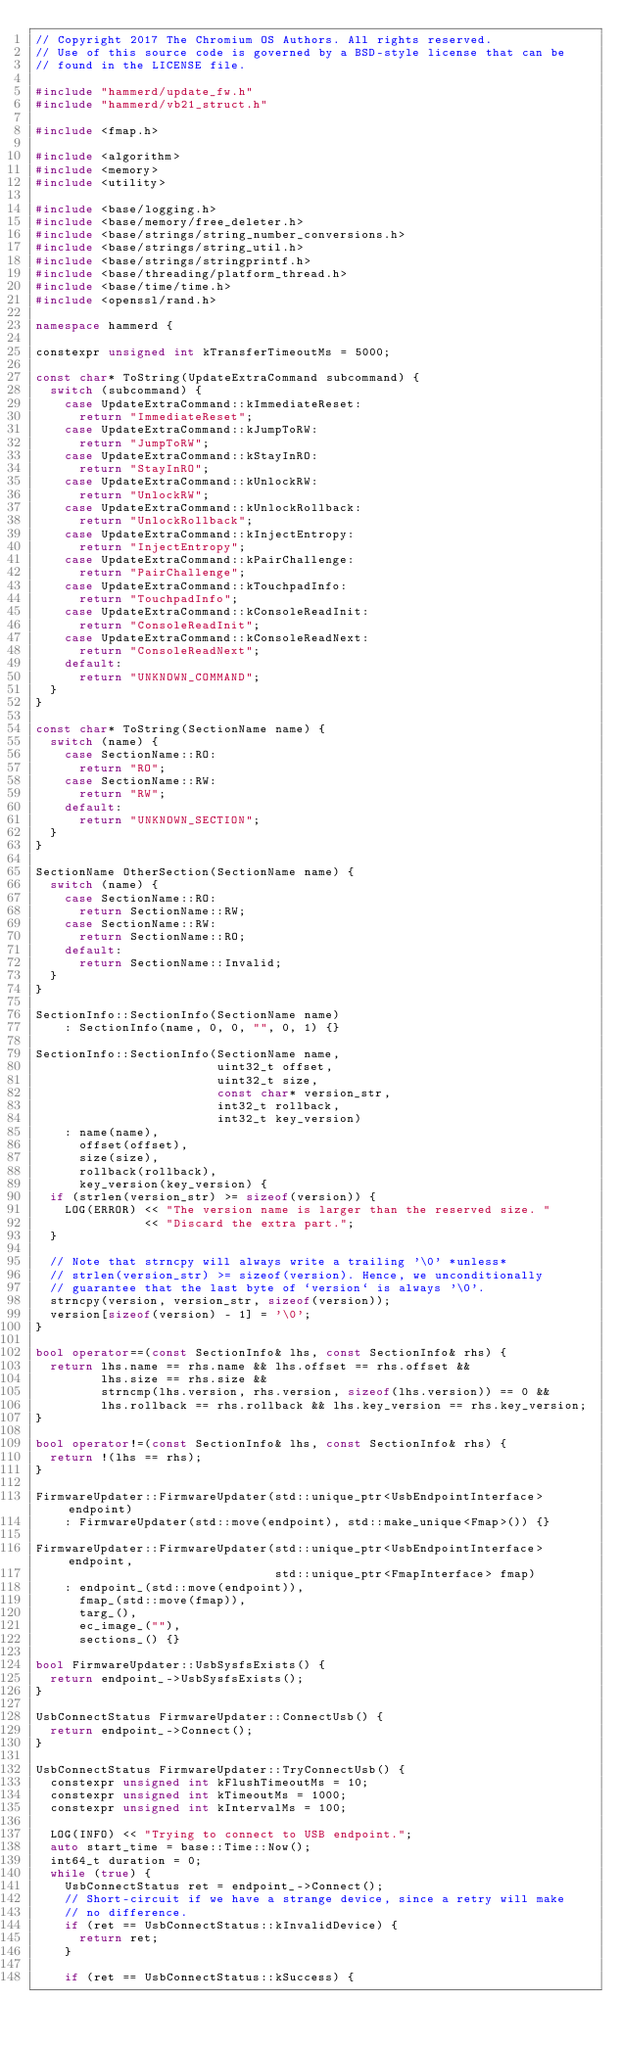<code> <loc_0><loc_0><loc_500><loc_500><_C++_>// Copyright 2017 The Chromium OS Authors. All rights reserved.
// Use of this source code is governed by a BSD-style license that can be
// found in the LICENSE file.

#include "hammerd/update_fw.h"
#include "hammerd/vb21_struct.h"

#include <fmap.h>

#include <algorithm>
#include <memory>
#include <utility>

#include <base/logging.h>
#include <base/memory/free_deleter.h>
#include <base/strings/string_number_conversions.h>
#include <base/strings/string_util.h>
#include <base/strings/stringprintf.h>
#include <base/threading/platform_thread.h>
#include <base/time/time.h>
#include <openssl/rand.h>

namespace hammerd {

constexpr unsigned int kTransferTimeoutMs = 5000;

const char* ToString(UpdateExtraCommand subcommand) {
  switch (subcommand) {
    case UpdateExtraCommand::kImmediateReset:
      return "ImmediateReset";
    case UpdateExtraCommand::kJumpToRW:
      return "JumpToRW";
    case UpdateExtraCommand::kStayInRO:
      return "StayInRO";
    case UpdateExtraCommand::kUnlockRW:
      return "UnlockRW";
    case UpdateExtraCommand::kUnlockRollback:
      return "UnlockRollback";
    case UpdateExtraCommand::kInjectEntropy:
      return "InjectEntropy";
    case UpdateExtraCommand::kPairChallenge:
      return "PairChallenge";
    case UpdateExtraCommand::kTouchpadInfo:
      return "TouchpadInfo";
    case UpdateExtraCommand::kConsoleReadInit:
      return "ConsoleReadInit";
    case UpdateExtraCommand::kConsoleReadNext:
      return "ConsoleReadNext";
    default:
      return "UNKNOWN_COMMAND";
  }
}

const char* ToString(SectionName name) {
  switch (name) {
    case SectionName::RO:
      return "RO";
    case SectionName::RW:
      return "RW";
    default:
      return "UNKNOWN_SECTION";
  }
}

SectionName OtherSection(SectionName name) {
  switch (name) {
    case SectionName::RO:
      return SectionName::RW;
    case SectionName::RW:
      return SectionName::RO;
    default:
      return SectionName::Invalid;
  }
}

SectionInfo::SectionInfo(SectionName name)
    : SectionInfo(name, 0, 0, "", 0, 1) {}

SectionInfo::SectionInfo(SectionName name,
                         uint32_t offset,
                         uint32_t size,
                         const char* version_str,
                         int32_t rollback,
                         int32_t key_version)
    : name(name),
      offset(offset),
      size(size),
      rollback(rollback),
      key_version(key_version) {
  if (strlen(version_str) >= sizeof(version)) {
    LOG(ERROR) << "The version name is larger than the reserved size. "
               << "Discard the extra part.";
  }

  // Note that strncpy will always write a trailing '\0' *unless*
  // strlen(version_str) >= sizeof(version). Hence, we unconditionally
  // guarantee that the last byte of `version` is always '\0'.
  strncpy(version, version_str, sizeof(version));
  version[sizeof(version) - 1] = '\0';
}

bool operator==(const SectionInfo& lhs, const SectionInfo& rhs) {
  return lhs.name == rhs.name && lhs.offset == rhs.offset &&
         lhs.size == rhs.size &&
         strncmp(lhs.version, rhs.version, sizeof(lhs.version)) == 0 &&
         lhs.rollback == rhs.rollback && lhs.key_version == rhs.key_version;
}

bool operator!=(const SectionInfo& lhs, const SectionInfo& rhs) {
  return !(lhs == rhs);
}

FirmwareUpdater::FirmwareUpdater(std::unique_ptr<UsbEndpointInterface> endpoint)
    : FirmwareUpdater(std::move(endpoint), std::make_unique<Fmap>()) {}

FirmwareUpdater::FirmwareUpdater(std::unique_ptr<UsbEndpointInterface> endpoint,
                                 std::unique_ptr<FmapInterface> fmap)
    : endpoint_(std::move(endpoint)),
      fmap_(std::move(fmap)),
      targ_(),
      ec_image_(""),
      sections_() {}

bool FirmwareUpdater::UsbSysfsExists() {
  return endpoint_->UsbSysfsExists();
}

UsbConnectStatus FirmwareUpdater::ConnectUsb() {
  return endpoint_->Connect();
}

UsbConnectStatus FirmwareUpdater::TryConnectUsb() {
  constexpr unsigned int kFlushTimeoutMs = 10;
  constexpr unsigned int kTimeoutMs = 1000;
  constexpr unsigned int kIntervalMs = 100;

  LOG(INFO) << "Trying to connect to USB endpoint.";
  auto start_time = base::Time::Now();
  int64_t duration = 0;
  while (true) {
    UsbConnectStatus ret = endpoint_->Connect();
    // Short-circuit if we have a strange device, since a retry will make
    // no difference.
    if (ret == UsbConnectStatus::kInvalidDevice) {
      return ret;
    }

    if (ret == UsbConnectStatus::kSuccess) {</code> 